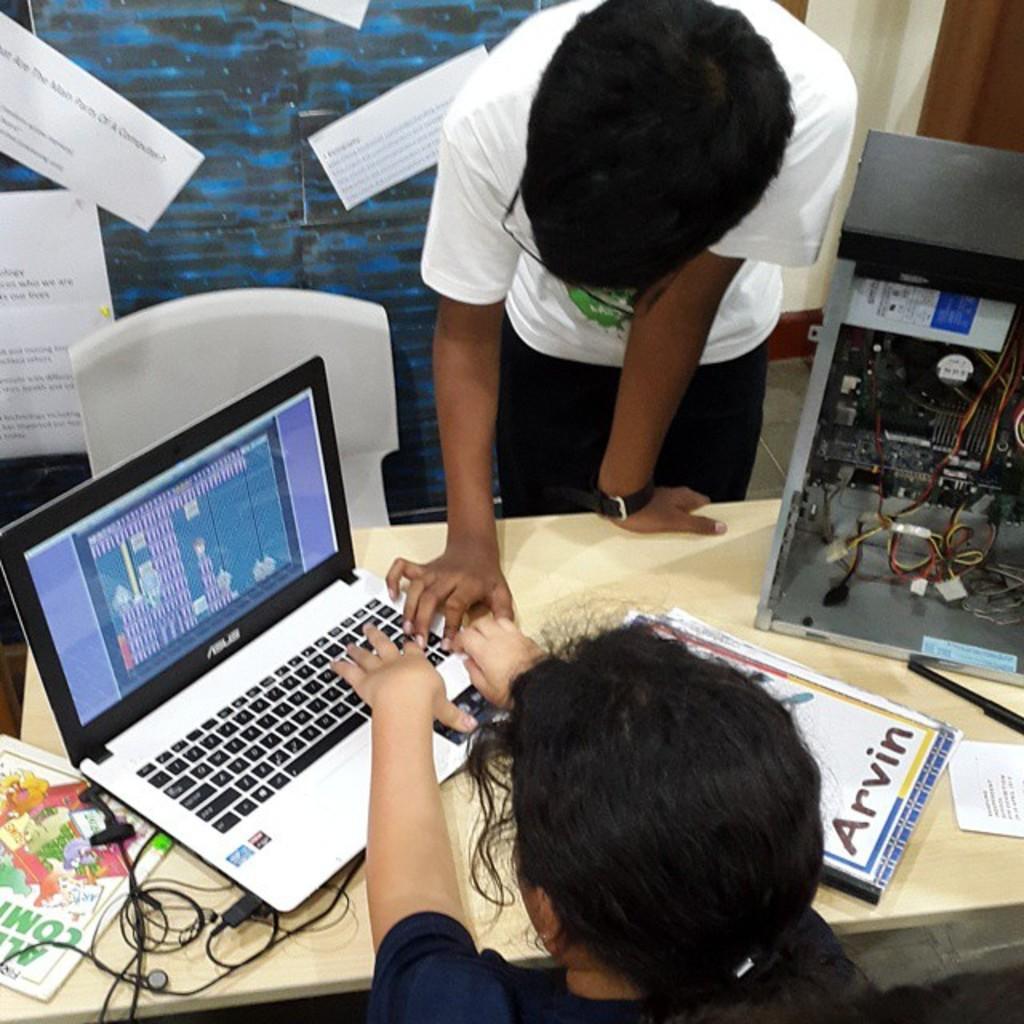In one or two sentences, can you explain what this image depicts? In the picture I can see a woman at the bottom of the image and she is working on a laptop. I can see the CPU, a pen, books and laptop are kept on the table. I can see a chair on the floor. I can see a man standing on the floor and he is having a look at the laptop. I can see the sheet of papers stick on the glass window on the top left side. 